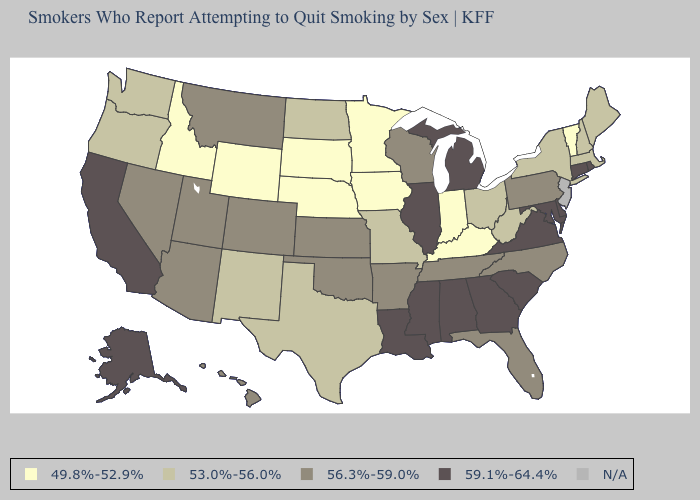Among the states that border Arkansas , does Texas have the highest value?
Keep it brief. No. Among the states that border South Carolina , which have the lowest value?
Be succinct. North Carolina. What is the value of Massachusetts?
Give a very brief answer. 53.0%-56.0%. Does Alabama have the highest value in the USA?
Concise answer only. Yes. Name the states that have a value in the range 49.8%-52.9%?
Concise answer only. Idaho, Indiana, Iowa, Kentucky, Minnesota, Nebraska, South Dakota, Vermont, Wyoming. What is the value of Idaho?
Write a very short answer. 49.8%-52.9%. What is the highest value in the West ?
Short answer required. 59.1%-64.4%. Name the states that have a value in the range 56.3%-59.0%?
Concise answer only. Arizona, Arkansas, Colorado, Florida, Hawaii, Kansas, Montana, Nevada, North Carolina, Oklahoma, Pennsylvania, Tennessee, Utah, Wisconsin. Does North Carolina have the highest value in the South?
Keep it brief. No. What is the highest value in states that border California?
Give a very brief answer. 56.3%-59.0%. What is the value of Maine?
Short answer required. 53.0%-56.0%. What is the highest value in the West ?
Quick response, please. 59.1%-64.4%. Name the states that have a value in the range 59.1%-64.4%?
Answer briefly. Alabama, Alaska, California, Connecticut, Delaware, Georgia, Illinois, Louisiana, Maryland, Michigan, Mississippi, Rhode Island, South Carolina, Virginia. What is the value of Maryland?
Write a very short answer. 59.1%-64.4%. What is the lowest value in states that border Rhode Island?
Write a very short answer. 53.0%-56.0%. 